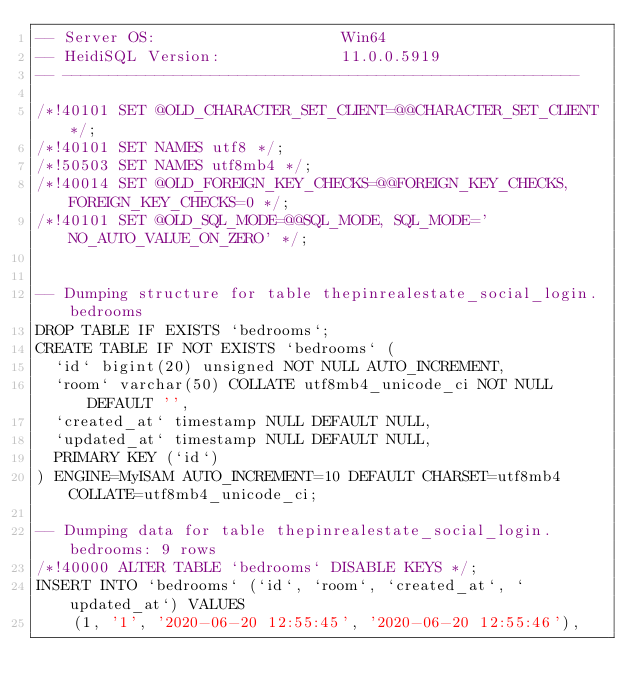Convert code to text. <code><loc_0><loc_0><loc_500><loc_500><_SQL_>-- Server OS:                    Win64
-- HeidiSQL Version:             11.0.0.5919
-- --------------------------------------------------------

/*!40101 SET @OLD_CHARACTER_SET_CLIENT=@@CHARACTER_SET_CLIENT */;
/*!40101 SET NAMES utf8 */;
/*!50503 SET NAMES utf8mb4 */;
/*!40014 SET @OLD_FOREIGN_KEY_CHECKS=@@FOREIGN_KEY_CHECKS, FOREIGN_KEY_CHECKS=0 */;
/*!40101 SET @OLD_SQL_MODE=@@SQL_MODE, SQL_MODE='NO_AUTO_VALUE_ON_ZERO' */;


-- Dumping structure for table thepinrealestate_social_login.bedrooms
DROP TABLE IF EXISTS `bedrooms`;
CREATE TABLE IF NOT EXISTS `bedrooms` (
  `id` bigint(20) unsigned NOT NULL AUTO_INCREMENT,
  `room` varchar(50) COLLATE utf8mb4_unicode_ci NOT NULL DEFAULT '',
  `created_at` timestamp NULL DEFAULT NULL,
  `updated_at` timestamp NULL DEFAULT NULL,
  PRIMARY KEY (`id`)
) ENGINE=MyISAM AUTO_INCREMENT=10 DEFAULT CHARSET=utf8mb4 COLLATE=utf8mb4_unicode_ci;

-- Dumping data for table thepinrealestate_social_login.bedrooms: 9 rows
/*!40000 ALTER TABLE `bedrooms` DISABLE KEYS */;
INSERT INTO `bedrooms` (`id`, `room`, `created_at`, `updated_at`) VALUES
	(1, '1', '2020-06-20 12:55:45', '2020-06-20 12:55:46'),</code> 